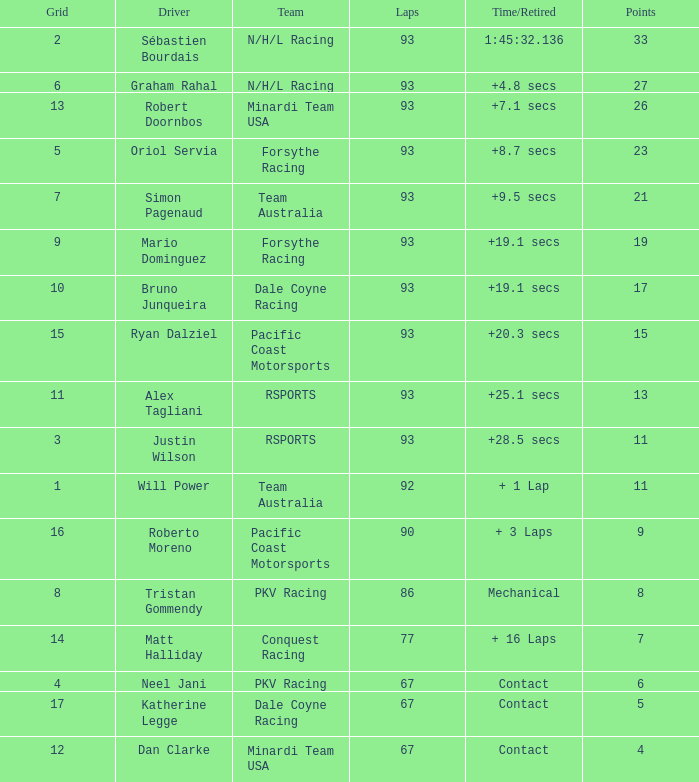What is the grid for the Minardi Team USA with laps smaller than 90? 12.0. 